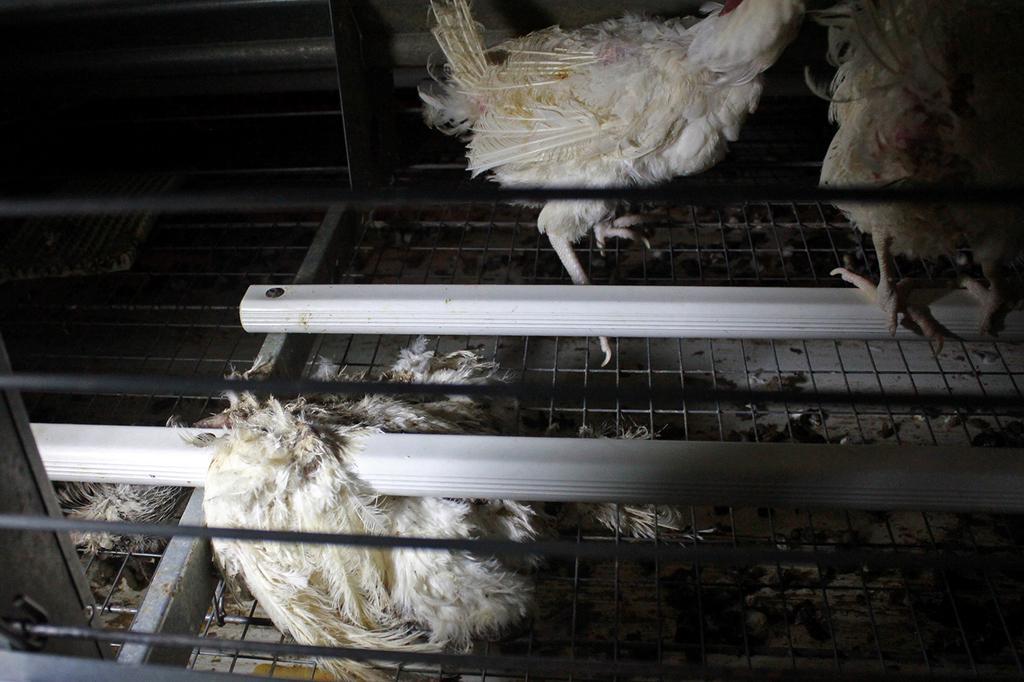Describe this image in one or two sentences. In this image, we can see hens on iron grills. 